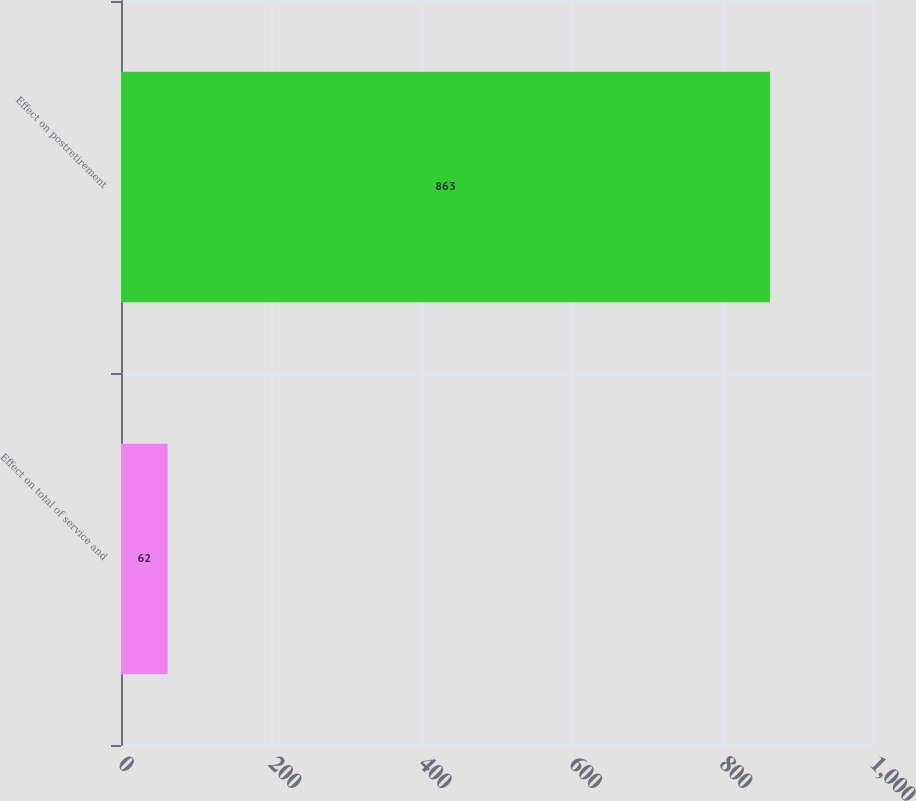Convert chart to OTSL. <chart><loc_0><loc_0><loc_500><loc_500><bar_chart><fcel>Effect on total of service and<fcel>Effect on postretirement<nl><fcel>62<fcel>863<nl></chart> 